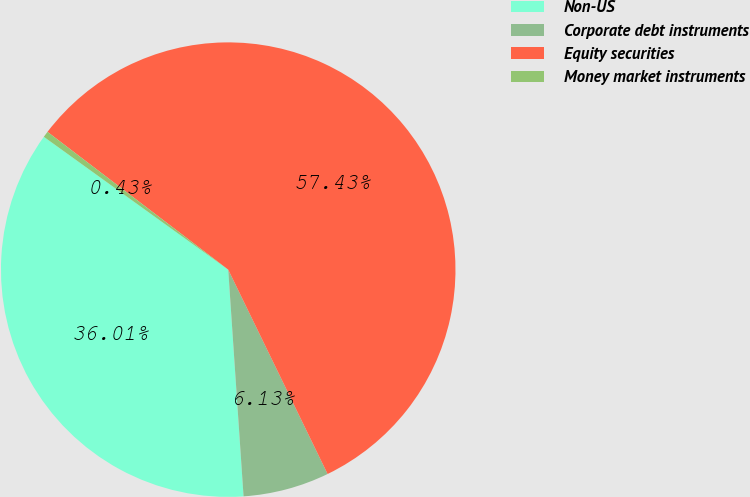Convert chart to OTSL. <chart><loc_0><loc_0><loc_500><loc_500><pie_chart><fcel>Non-US<fcel>Corporate debt instruments<fcel>Equity securities<fcel>Money market instruments<nl><fcel>36.01%<fcel>6.13%<fcel>57.43%<fcel>0.43%<nl></chart> 